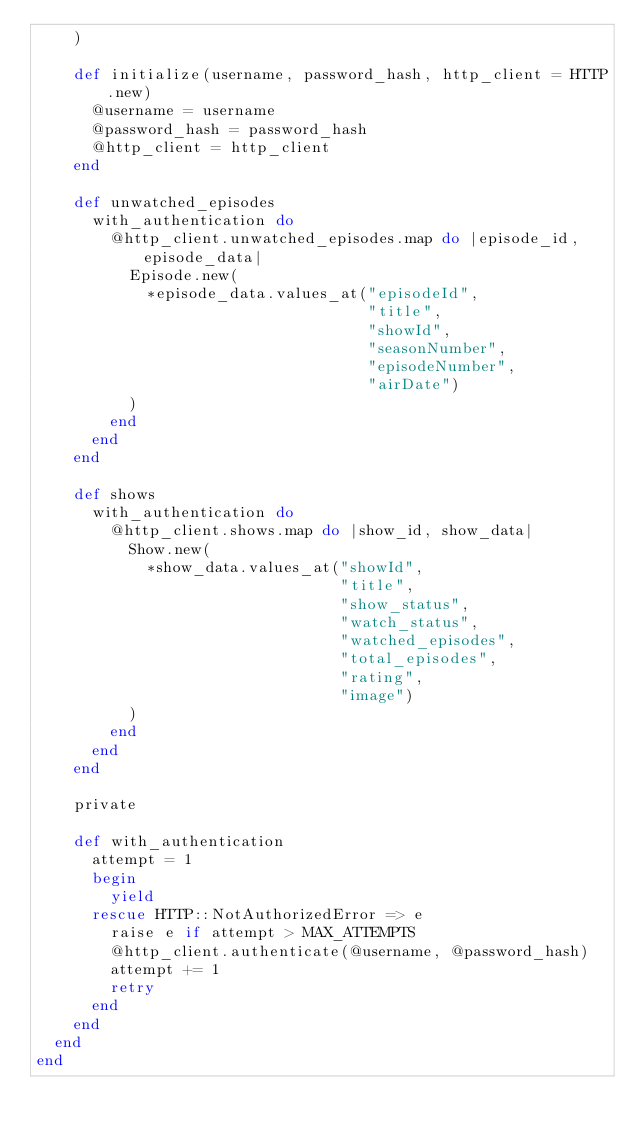<code> <loc_0><loc_0><loc_500><loc_500><_Ruby_>    )

    def initialize(username, password_hash, http_client = HTTP.new)
      @username = username
      @password_hash = password_hash
      @http_client = http_client
    end

    def unwatched_episodes
      with_authentication do
        @http_client.unwatched_episodes.map do |episode_id, episode_data|
          Episode.new(
            *episode_data.values_at("episodeId",
                                    "title",
                                    "showId",
                                    "seasonNumber",
                                    "episodeNumber",
                                    "airDate")
          )
        end
      end
    end

    def shows
      with_authentication do
        @http_client.shows.map do |show_id, show_data|
          Show.new(
            *show_data.values_at("showId",
                                 "title",
                                 "show_status",
                                 "watch_status",
                                 "watched_episodes",
                                 "total_episodes",
                                 "rating",
                                 "image")
          )
        end
      end
    end

    private

    def with_authentication
      attempt = 1
      begin
        yield
      rescue HTTP::NotAuthorizedError => e
        raise e if attempt > MAX_ATTEMPTS
        @http_client.authenticate(@username, @password_hash)
        attempt += 1
        retry
      end
    end
  end
end
</code> 